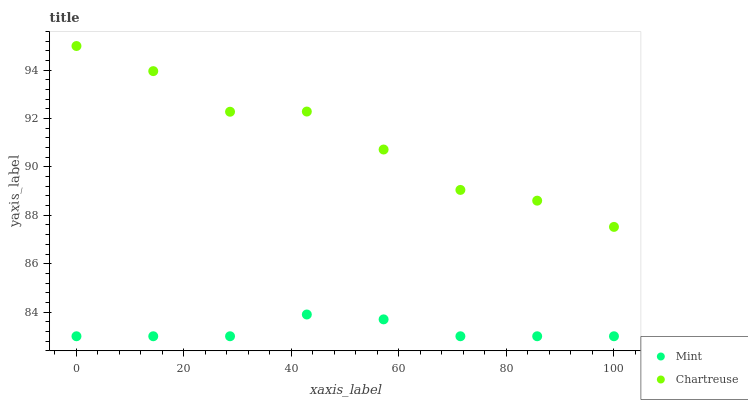Does Mint have the minimum area under the curve?
Answer yes or no. Yes. Does Chartreuse have the maximum area under the curve?
Answer yes or no. Yes. Does Mint have the maximum area under the curve?
Answer yes or no. No. Is Mint the smoothest?
Answer yes or no. Yes. Is Chartreuse the roughest?
Answer yes or no. Yes. Is Mint the roughest?
Answer yes or no. No. Does Mint have the lowest value?
Answer yes or no. Yes. Does Chartreuse have the highest value?
Answer yes or no. Yes. Does Mint have the highest value?
Answer yes or no. No. Is Mint less than Chartreuse?
Answer yes or no. Yes. Is Chartreuse greater than Mint?
Answer yes or no. Yes. Does Mint intersect Chartreuse?
Answer yes or no. No. 